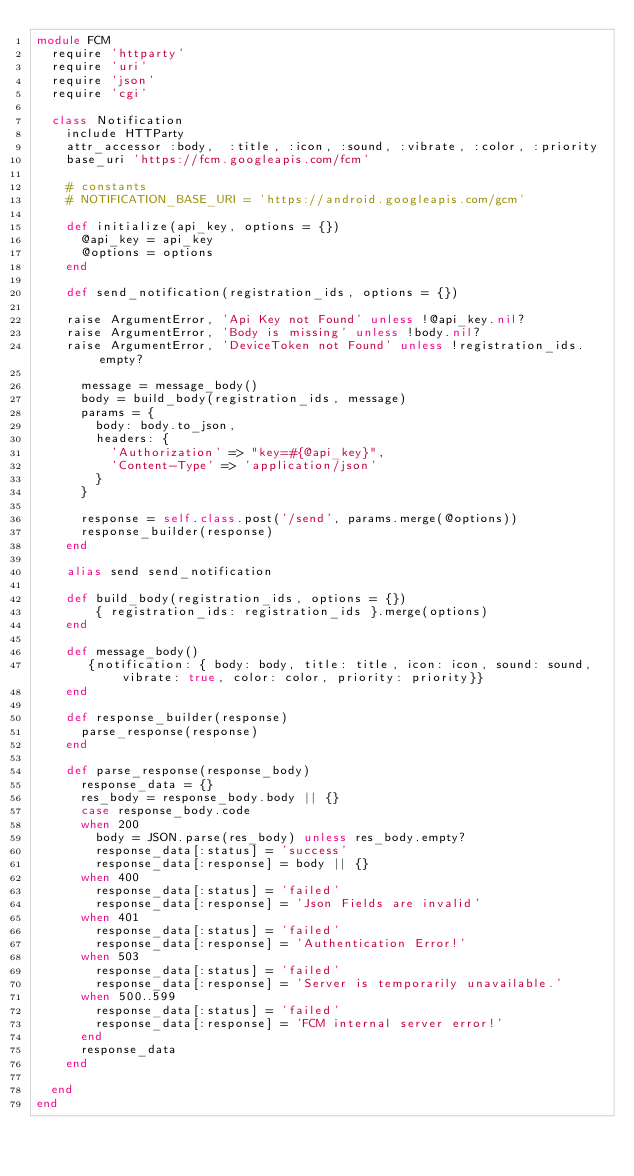<code> <loc_0><loc_0><loc_500><loc_500><_Ruby_>module FCM
  require 'httparty'
  require 'uri'
  require 'json'
  require 'cgi'

  class Notification
    include HTTParty
    attr_accessor :body,  :title, :icon, :sound, :vibrate, :color, :priority
    base_uri 'https://fcm.googleapis.com/fcm'

    # constants
    # NOTIFICATION_BASE_URI = 'https://android.googleapis.com/gcm'

    def initialize(api_key, options = {})
      @api_key = api_key
      @options = options
    end

    def send_notification(registration_ids, options = {})

    raise ArgumentError, 'Api Key not Found' unless !@api_key.nil?
    raise ArgumentError, 'Body is missing' unless !body.nil?
    raise ArgumentError, 'DeviceToken not Found' unless !registration_ids.empty?

      message = message_body()
      body = build_body(registration_ids, message)
      params = {
        body: body.to_json,
        headers: {
          'Authorization' => "key=#{@api_key}",
          'Content-Type' => 'application/json'
        }
      }

      response = self.class.post('/send', params.merge(@options))
      response_builder(response)
    end

    alias send send_notification

    def build_body(registration_ids, options = {})
        { registration_ids: registration_ids }.merge(options)
    end

    def message_body()
       {notification: { body: body, title: title, icon: icon, sound: sound, vibrate: true, color: color, priority: priority}}
    end

    def response_builder(response)
      parse_response(response)
    end

    def parse_response(response_body)
      response_data = {}
      res_body = response_body.body || {}
      case response_body.code
      when 200
        body = JSON.parse(res_body) unless res_body.empty?
        response_data[:status] = 'success'
        response_data[:response] = body || {}
      when 400
        response_data[:status] = 'failed'
        response_data[:response] = 'Json Fields are invalid'
      when 401
        response_data[:status] = 'failed'
        response_data[:response] = 'Authentication Error!'
      when 503
        response_data[:status] = 'failed'
        response_data[:response] = 'Server is temporarily unavailable.'
      when 500..599
        response_data[:status] = 'failed'
        response_data[:response] = 'FCM internal server error!'
      end
      response_data
    end

  end
end
</code> 